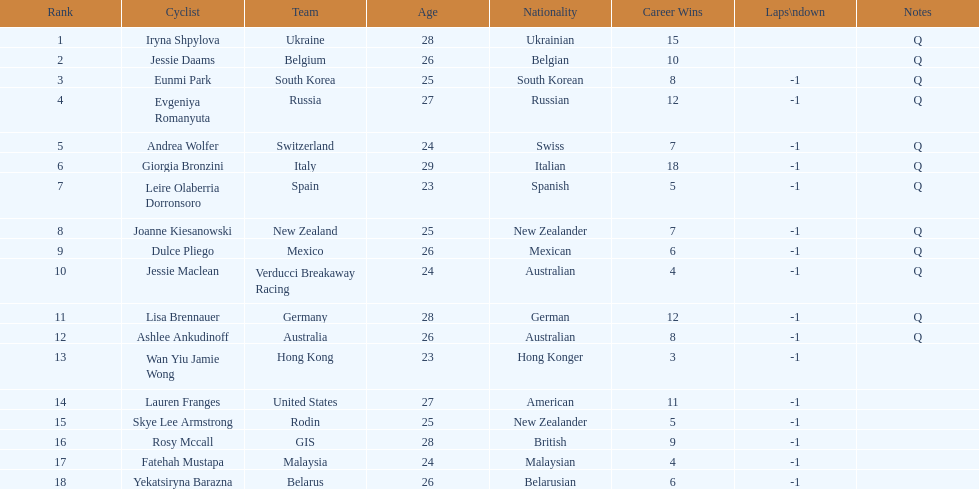Who was the top ranked competitor in this race? Iryna Shpylova. 